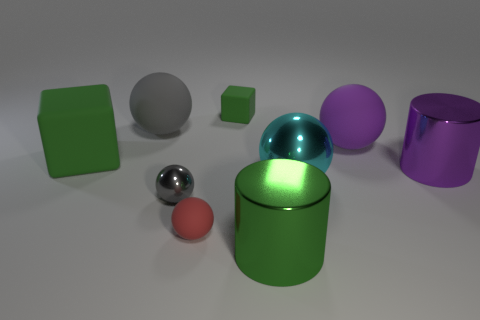Subtract all cyan balls. How many balls are left? 4 Add 1 purple cylinders. How many objects exist? 10 Subtract all cylinders. How many objects are left? 7 Add 5 tiny red things. How many tiny red things exist? 6 Subtract 1 red balls. How many objects are left? 8 Subtract all small green cubes. Subtract all big cubes. How many objects are left? 7 Add 7 large green cylinders. How many large green cylinders are left? 8 